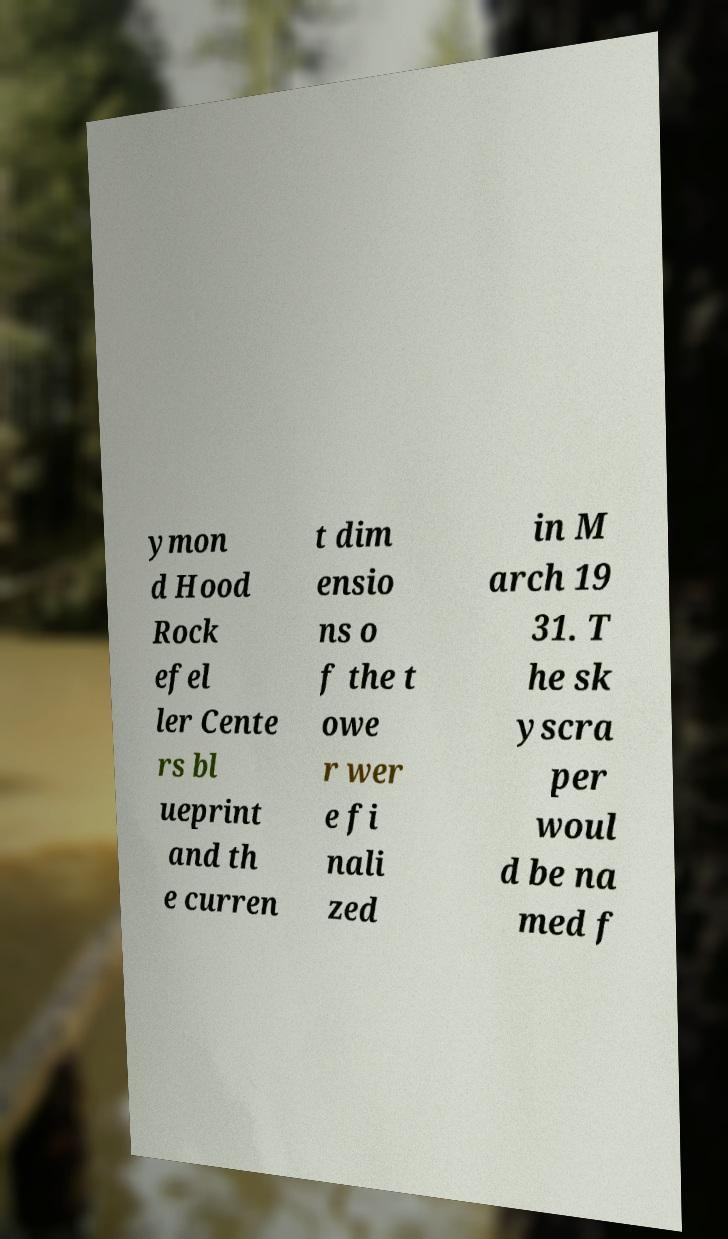Can you accurately transcribe the text from the provided image for me? ymon d Hood Rock efel ler Cente rs bl ueprint and th e curren t dim ensio ns o f the t owe r wer e fi nali zed in M arch 19 31. T he sk yscra per woul d be na med f 